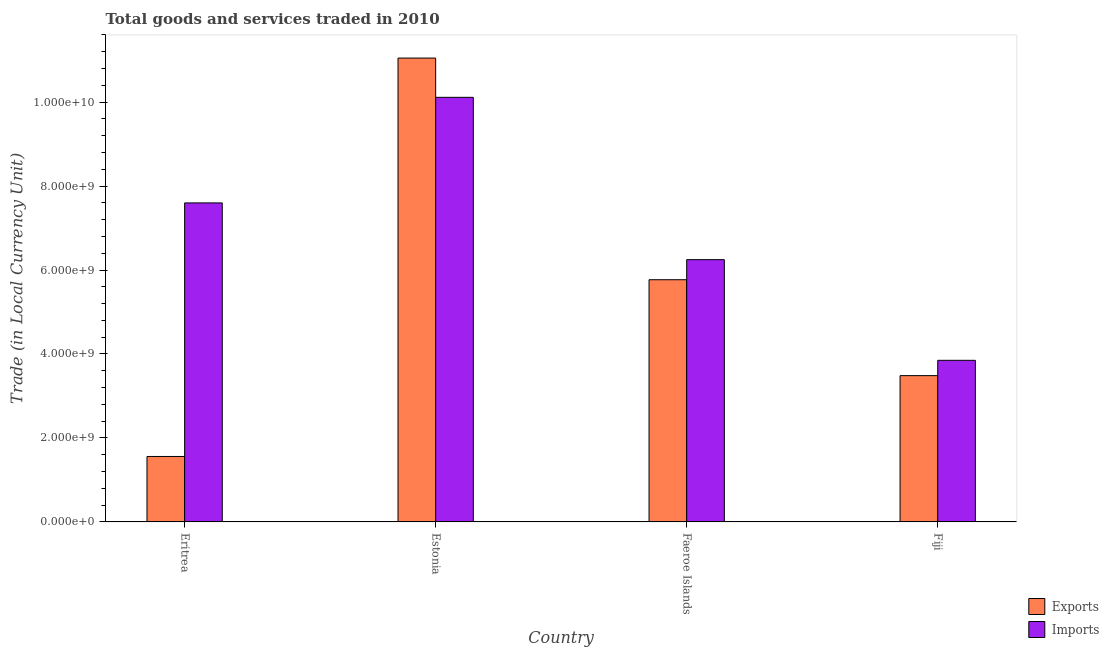Are the number of bars per tick equal to the number of legend labels?
Give a very brief answer. Yes. Are the number of bars on each tick of the X-axis equal?
Your answer should be very brief. Yes. What is the label of the 4th group of bars from the left?
Make the answer very short. Fiji. What is the export of goods and services in Fiji?
Keep it short and to the point. 3.48e+09. Across all countries, what is the maximum export of goods and services?
Provide a succinct answer. 1.10e+1. Across all countries, what is the minimum export of goods and services?
Keep it short and to the point. 1.56e+09. In which country was the export of goods and services maximum?
Provide a succinct answer. Estonia. In which country was the imports of goods and services minimum?
Your answer should be very brief. Fiji. What is the total export of goods and services in the graph?
Ensure brevity in your answer.  2.19e+1. What is the difference between the imports of goods and services in Estonia and that in Fiji?
Keep it short and to the point. 6.26e+09. What is the difference between the export of goods and services in Estonia and the imports of goods and services in Eritrea?
Keep it short and to the point. 3.45e+09. What is the average imports of goods and services per country?
Your answer should be very brief. 6.95e+09. What is the difference between the export of goods and services and imports of goods and services in Eritrea?
Your response must be concise. -6.04e+09. In how many countries, is the imports of goods and services greater than 2400000000 LCU?
Keep it short and to the point. 4. What is the ratio of the export of goods and services in Estonia to that in Fiji?
Offer a very short reply. 3.17. Is the difference between the export of goods and services in Estonia and Faeroe Islands greater than the difference between the imports of goods and services in Estonia and Faeroe Islands?
Ensure brevity in your answer.  Yes. What is the difference between the highest and the second highest export of goods and services?
Give a very brief answer. 5.28e+09. What is the difference between the highest and the lowest imports of goods and services?
Your response must be concise. 6.26e+09. In how many countries, is the export of goods and services greater than the average export of goods and services taken over all countries?
Offer a very short reply. 2. What does the 2nd bar from the left in Eritrea represents?
Your response must be concise. Imports. What does the 1st bar from the right in Estonia represents?
Give a very brief answer. Imports. Are all the bars in the graph horizontal?
Ensure brevity in your answer.  No. How many countries are there in the graph?
Keep it short and to the point. 4. How are the legend labels stacked?
Your answer should be compact. Vertical. What is the title of the graph?
Ensure brevity in your answer.  Total goods and services traded in 2010. Does "Lower secondary rate" appear as one of the legend labels in the graph?
Provide a short and direct response. No. What is the label or title of the Y-axis?
Your answer should be compact. Trade (in Local Currency Unit). What is the Trade (in Local Currency Unit) of Exports in Eritrea?
Offer a very short reply. 1.56e+09. What is the Trade (in Local Currency Unit) of Imports in Eritrea?
Offer a terse response. 7.60e+09. What is the Trade (in Local Currency Unit) in Exports in Estonia?
Your response must be concise. 1.10e+1. What is the Trade (in Local Currency Unit) in Imports in Estonia?
Make the answer very short. 1.01e+1. What is the Trade (in Local Currency Unit) in Exports in Faeroe Islands?
Provide a short and direct response. 5.77e+09. What is the Trade (in Local Currency Unit) in Imports in Faeroe Islands?
Offer a very short reply. 6.25e+09. What is the Trade (in Local Currency Unit) of Exports in Fiji?
Your answer should be very brief. 3.48e+09. What is the Trade (in Local Currency Unit) in Imports in Fiji?
Keep it short and to the point. 3.85e+09. Across all countries, what is the maximum Trade (in Local Currency Unit) of Exports?
Provide a succinct answer. 1.10e+1. Across all countries, what is the maximum Trade (in Local Currency Unit) of Imports?
Offer a terse response. 1.01e+1. Across all countries, what is the minimum Trade (in Local Currency Unit) in Exports?
Give a very brief answer. 1.56e+09. Across all countries, what is the minimum Trade (in Local Currency Unit) in Imports?
Make the answer very short. 3.85e+09. What is the total Trade (in Local Currency Unit) in Exports in the graph?
Make the answer very short. 2.19e+1. What is the total Trade (in Local Currency Unit) of Imports in the graph?
Keep it short and to the point. 2.78e+1. What is the difference between the Trade (in Local Currency Unit) in Exports in Eritrea and that in Estonia?
Provide a short and direct response. -9.49e+09. What is the difference between the Trade (in Local Currency Unit) of Imports in Eritrea and that in Estonia?
Your answer should be very brief. -2.51e+09. What is the difference between the Trade (in Local Currency Unit) in Exports in Eritrea and that in Faeroe Islands?
Offer a very short reply. -4.21e+09. What is the difference between the Trade (in Local Currency Unit) in Imports in Eritrea and that in Faeroe Islands?
Give a very brief answer. 1.35e+09. What is the difference between the Trade (in Local Currency Unit) in Exports in Eritrea and that in Fiji?
Keep it short and to the point. -1.93e+09. What is the difference between the Trade (in Local Currency Unit) of Imports in Eritrea and that in Fiji?
Offer a terse response. 3.75e+09. What is the difference between the Trade (in Local Currency Unit) of Exports in Estonia and that in Faeroe Islands?
Give a very brief answer. 5.28e+09. What is the difference between the Trade (in Local Currency Unit) of Imports in Estonia and that in Faeroe Islands?
Your answer should be very brief. 3.87e+09. What is the difference between the Trade (in Local Currency Unit) of Exports in Estonia and that in Fiji?
Make the answer very short. 7.56e+09. What is the difference between the Trade (in Local Currency Unit) of Imports in Estonia and that in Fiji?
Ensure brevity in your answer.  6.26e+09. What is the difference between the Trade (in Local Currency Unit) of Exports in Faeroe Islands and that in Fiji?
Ensure brevity in your answer.  2.28e+09. What is the difference between the Trade (in Local Currency Unit) in Imports in Faeroe Islands and that in Fiji?
Give a very brief answer. 2.40e+09. What is the difference between the Trade (in Local Currency Unit) of Exports in Eritrea and the Trade (in Local Currency Unit) of Imports in Estonia?
Offer a very short reply. -8.55e+09. What is the difference between the Trade (in Local Currency Unit) in Exports in Eritrea and the Trade (in Local Currency Unit) in Imports in Faeroe Islands?
Provide a short and direct response. -4.69e+09. What is the difference between the Trade (in Local Currency Unit) in Exports in Eritrea and the Trade (in Local Currency Unit) in Imports in Fiji?
Provide a short and direct response. -2.29e+09. What is the difference between the Trade (in Local Currency Unit) of Exports in Estonia and the Trade (in Local Currency Unit) of Imports in Faeroe Islands?
Your answer should be very brief. 4.80e+09. What is the difference between the Trade (in Local Currency Unit) of Exports in Estonia and the Trade (in Local Currency Unit) of Imports in Fiji?
Ensure brevity in your answer.  7.20e+09. What is the difference between the Trade (in Local Currency Unit) in Exports in Faeroe Islands and the Trade (in Local Currency Unit) in Imports in Fiji?
Provide a succinct answer. 1.92e+09. What is the average Trade (in Local Currency Unit) of Exports per country?
Your answer should be compact. 5.47e+09. What is the average Trade (in Local Currency Unit) in Imports per country?
Offer a very short reply. 6.95e+09. What is the difference between the Trade (in Local Currency Unit) in Exports and Trade (in Local Currency Unit) in Imports in Eritrea?
Keep it short and to the point. -6.04e+09. What is the difference between the Trade (in Local Currency Unit) in Exports and Trade (in Local Currency Unit) in Imports in Estonia?
Your response must be concise. 9.35e+08. What is the difference between the Trade (in Local Currency Unit) of Exports and Trade (in Local Currency Unit) of Imports in Faeroe Islands?
Your response must be concise. -4.78e+08. What is the difference between the Trade (in Local Currency Unit) of Exports and Trade (in Local Currency Unit) of Imports in Fiji?
Give a very brief answer. -3.65e+08. What is the ratio of the Trade (in Local Currency Unit) in Exports in Eritrea to that in Estonia?
Your answer should be compact. 0.14. What is the ratio of the Trade (in Local Currency Unit) in Imports in Eritrea to that in Estonia?
Your response must be concise. 0.75. What is the ratio of the Trade (in Local Currency Unit) in Exports in Eritrea to that in Faeroe Islands?
Your response must be concise. 0.27. What is the ratio of the Trade (in Local Currency Unit) of Imports in Eritrea to that in Faeroe Islands?
Your answer should be compact. 1.22. What is the ratio of the Trade (in Local Currency Unit) in Exports in Eritrea to that in Fiji?
Offer a very short reply. 0.45. What is the ratio of the Trade (in Local Currency Unit) in Imports in Eritrea to that in Fiji?
Give a very brief answer. 1.97. What is the ratio of the Trade (in Local Currency Unit) of Exports in Estonia to that in Faeroe Islands?
Offer a very short reply. 1.92. What is the ratio of the Trade (in Local Currency Unit) in Imports in Estonia to that in Faeroe Islands?
Offer a terse response. 1.62. What is the ratio of the Trade (in Local Currency Unit) in Exports in Estonia to that in Fiji?
Keep it short and to the point. 3.17. What is the ratio of the Trade (in Local Currency Unit) of Imports in Estonia to that in Fiji?
Provide a short and direct response. 2.63. What is the ratio of the Trade (in Local Currency Unit) in Exports in Faeroe Islands to that in Fiji?
Your response must be concise. 1.66. What is the ratio of the Trade (in Local Currency Unit) of Imports in Faeroe Islands to that in Fiji?
Make the answer very short. 1.62. What is the difference between the highest and the second highest Trade (in Local Currency Unit) in Exports?
Give a very brief answer. 5.28e+09. What is the difference between the highest and the second highest Trade (in Local Currency Unit) in Imports?
Give a very brief answer. 2.51e+09. What is the difference between the highest and the lowest Trade (in Local Currency Unit) of Exports?
Your answer should be compact. 9.49e+09. What is the difference between the highest and the lowest Trade (in Local Currency Unit) in Imports?
Offer a terse response. 6.26e+09. 